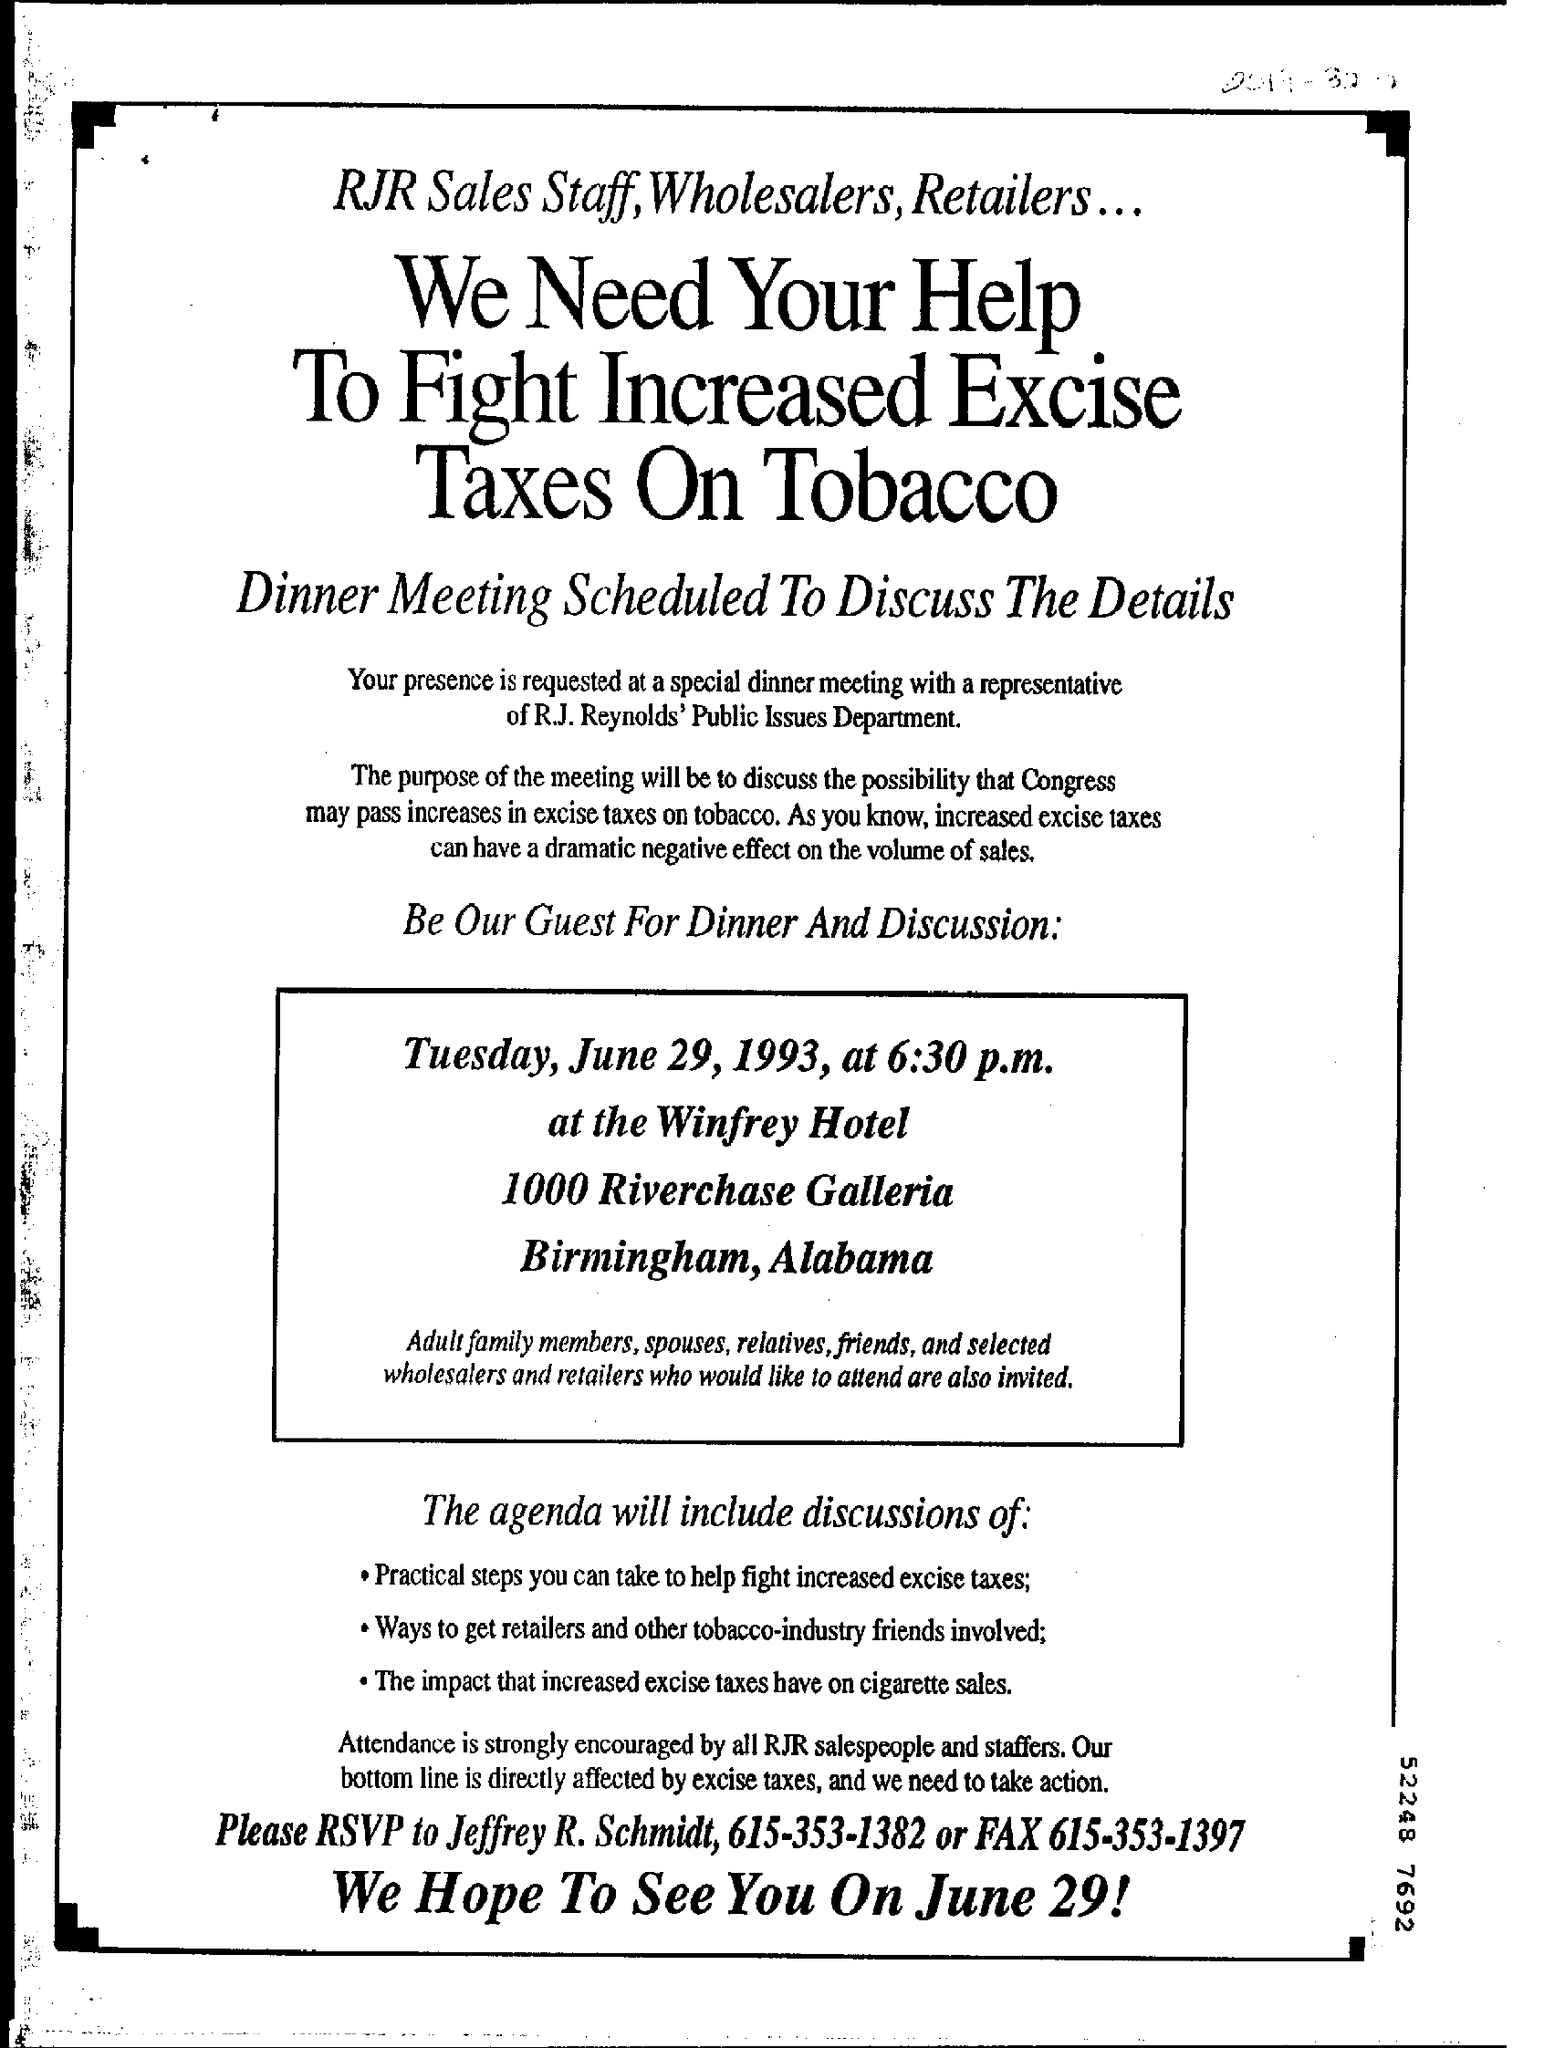What time is the dinner and discussion?
Give a very brief answer. 6:30 p.m. Who is the RSVP to be sent to?
Keep it short and to the point. Jeffrey R. Schmidt. 